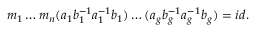Convert formula to latex. <formula><loc_0><loc_0><loc_500><loc_500>m _ { 1 } \dots m _ { n } ( a _ { 1 } b _ { 1 } ^ { - 1 } a _ { 1 } ^ { - 1 } b _ { 1 } ) \dots ( a _ { g } b _ { g } ^ { - 1 } a _ { g } ^ { - 1 } b _ { g } ) = i d .</formula> 